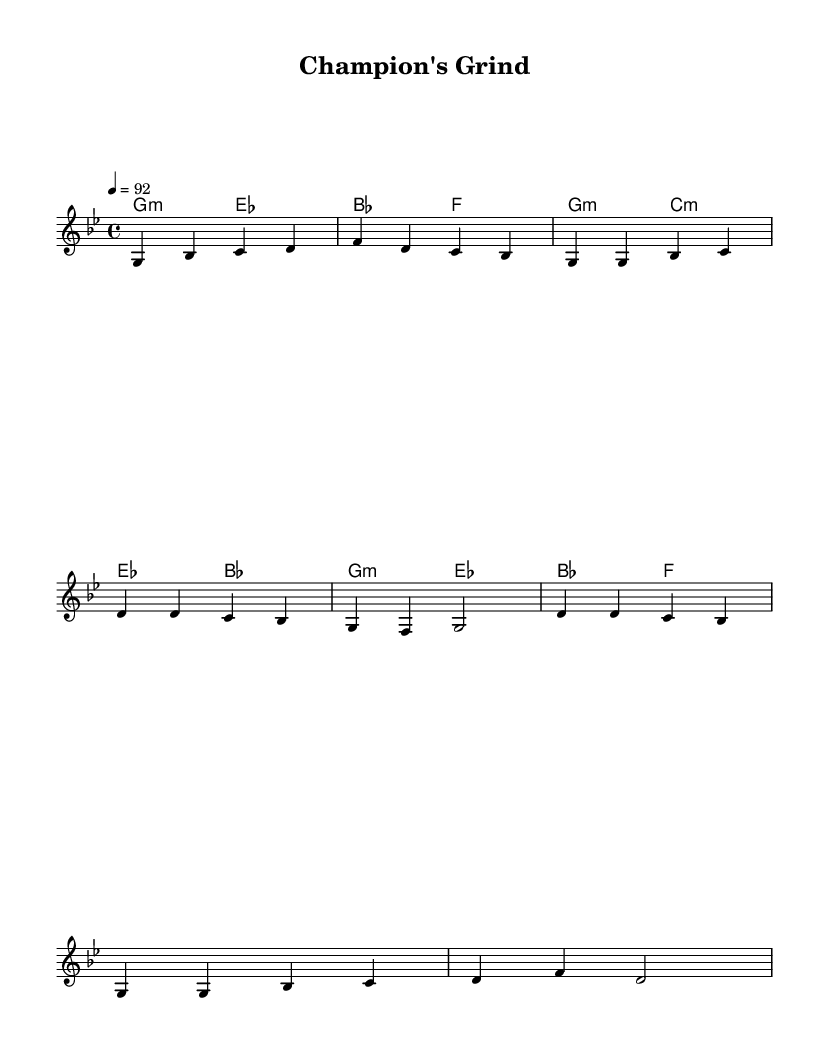What is the key signature of this music? The key signature is G minor, which contains two flats (B-flat and E-flat). This is indicated at the beginning of the sheet music.
Answer: G minor What is the time signature of this music? The time signature is 4/4, which means there are four beats per measure and a quarter note gets one beat. This can be observed at the beginning of the score.
Answer: 4/4 What is the tempo marking of the piece? The tempo marking is 92, indicating that the piece should be played at a speed of 92 beats per minute. This is typically found in the tempo indication at the start of the score.
Answer: 92 How many measures are in the chorus section? The chorus consists of 4 measures, as counted from the notation where the chorus part begins and ends. Each measure contains distinct notes giving a clear structure.
Answer: 4 In which section does the melody first reach a high note (d')? The melody first reaches a high note (d') in the chorus section. This can be identified where the note rises above the previous lower notes in the overall structure.
Answer: Chorus What are the harmony chords used in the chorus? The harmony chords in the chorus are G minor, E-flat major, and B-flat major, which are indicated in the chord symbols beneath the melody line.
Answer: G minor, E-flat major, B-flat major What is the last note of the melody in the verse? The last note of the melody in the verse is G. This can be traced by looking at the notes in the melody section and identifying the final note of that particular segment.
Answer: G 